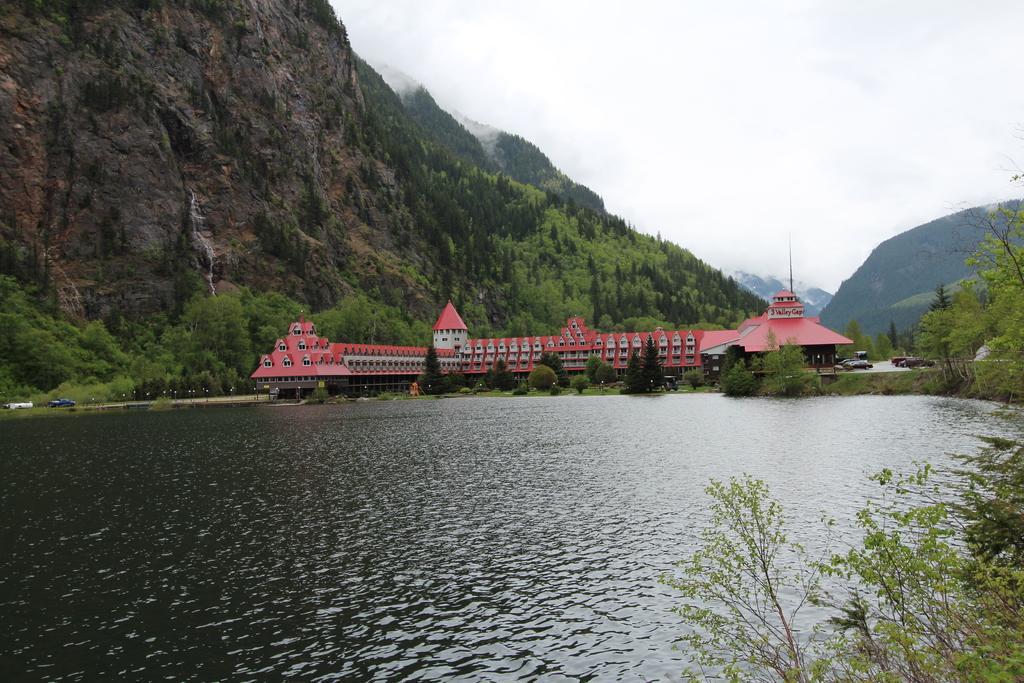Describe this image in one or two sentences. In this image I can see the lake , in front of the lake I can see the sky, hill and tees 